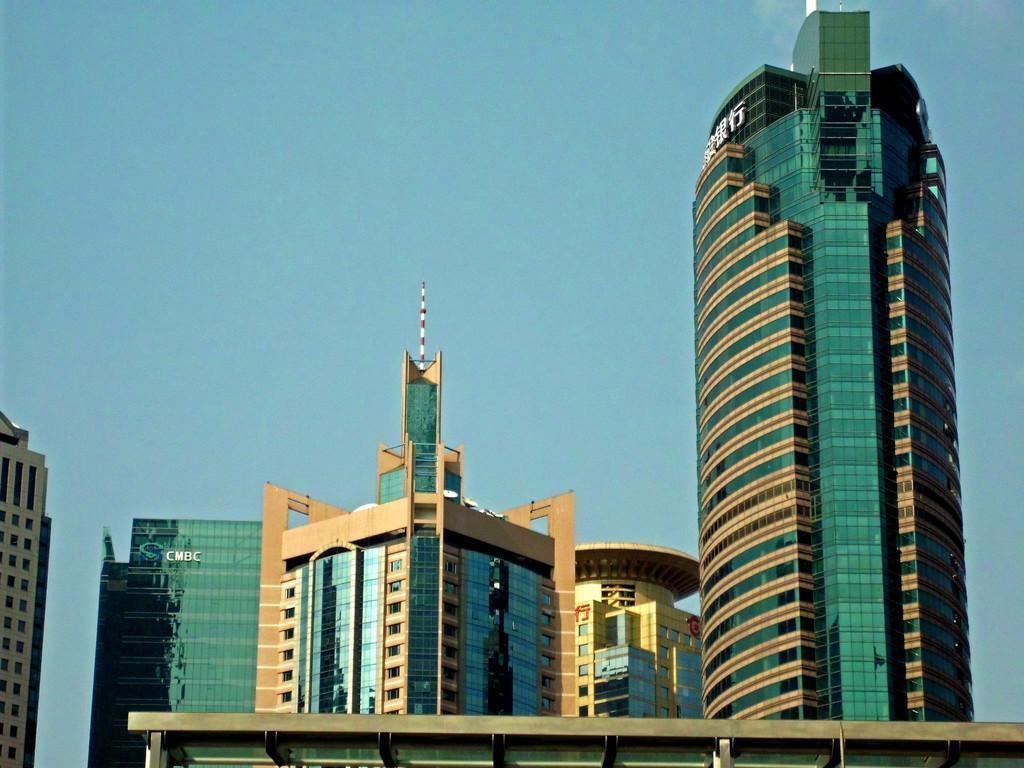Describe this image in one or two sentences. In this image there are tall buildings with glasses. There is sky. 